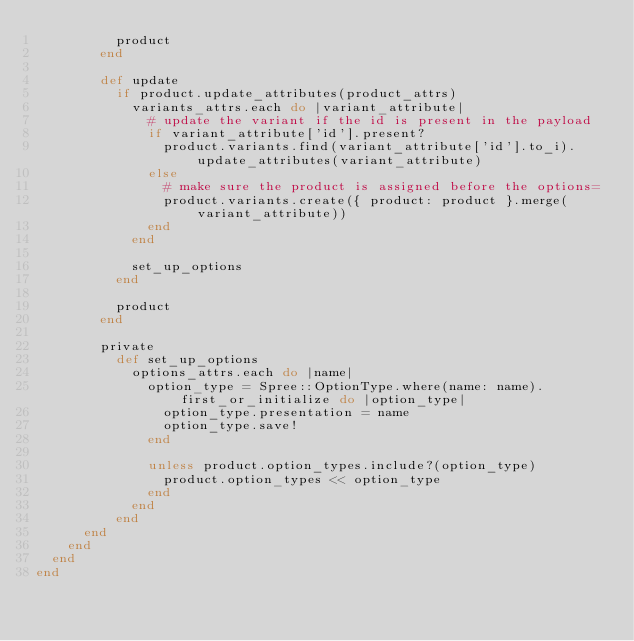<code> <loc_0><loc_0><loc_500><loc_500><_Ruby_>          product
        end

        def update
          if product.update_attributes(product_attrs)
            variants_attrs.each do |variant_attribute|
              # update the variant if the id is present in the payload
              if variant_attribute['id'].present?
                product.variants.find(variant_attribute['id'].to_i).update_attributes(variant_attribute)
              else
                # make sure the product is assigned before the options=
                product.variants.create({ product: product }.merge(variant_attribute))
              end
            end

            set_up_options
          end

          product
        end

        private
          def set_up_options
            options_attrs.each do |name|
              option_type = Spree::OptionType.where(name: name).first_or_initialize do |option_type|
                option_type.presentation = name
                option_type.save!
              end

              unless product.option_types.include?(option_type)
                product.option_types << option_type
              end
            end
          end
      end
    end
  end
end
</code> 